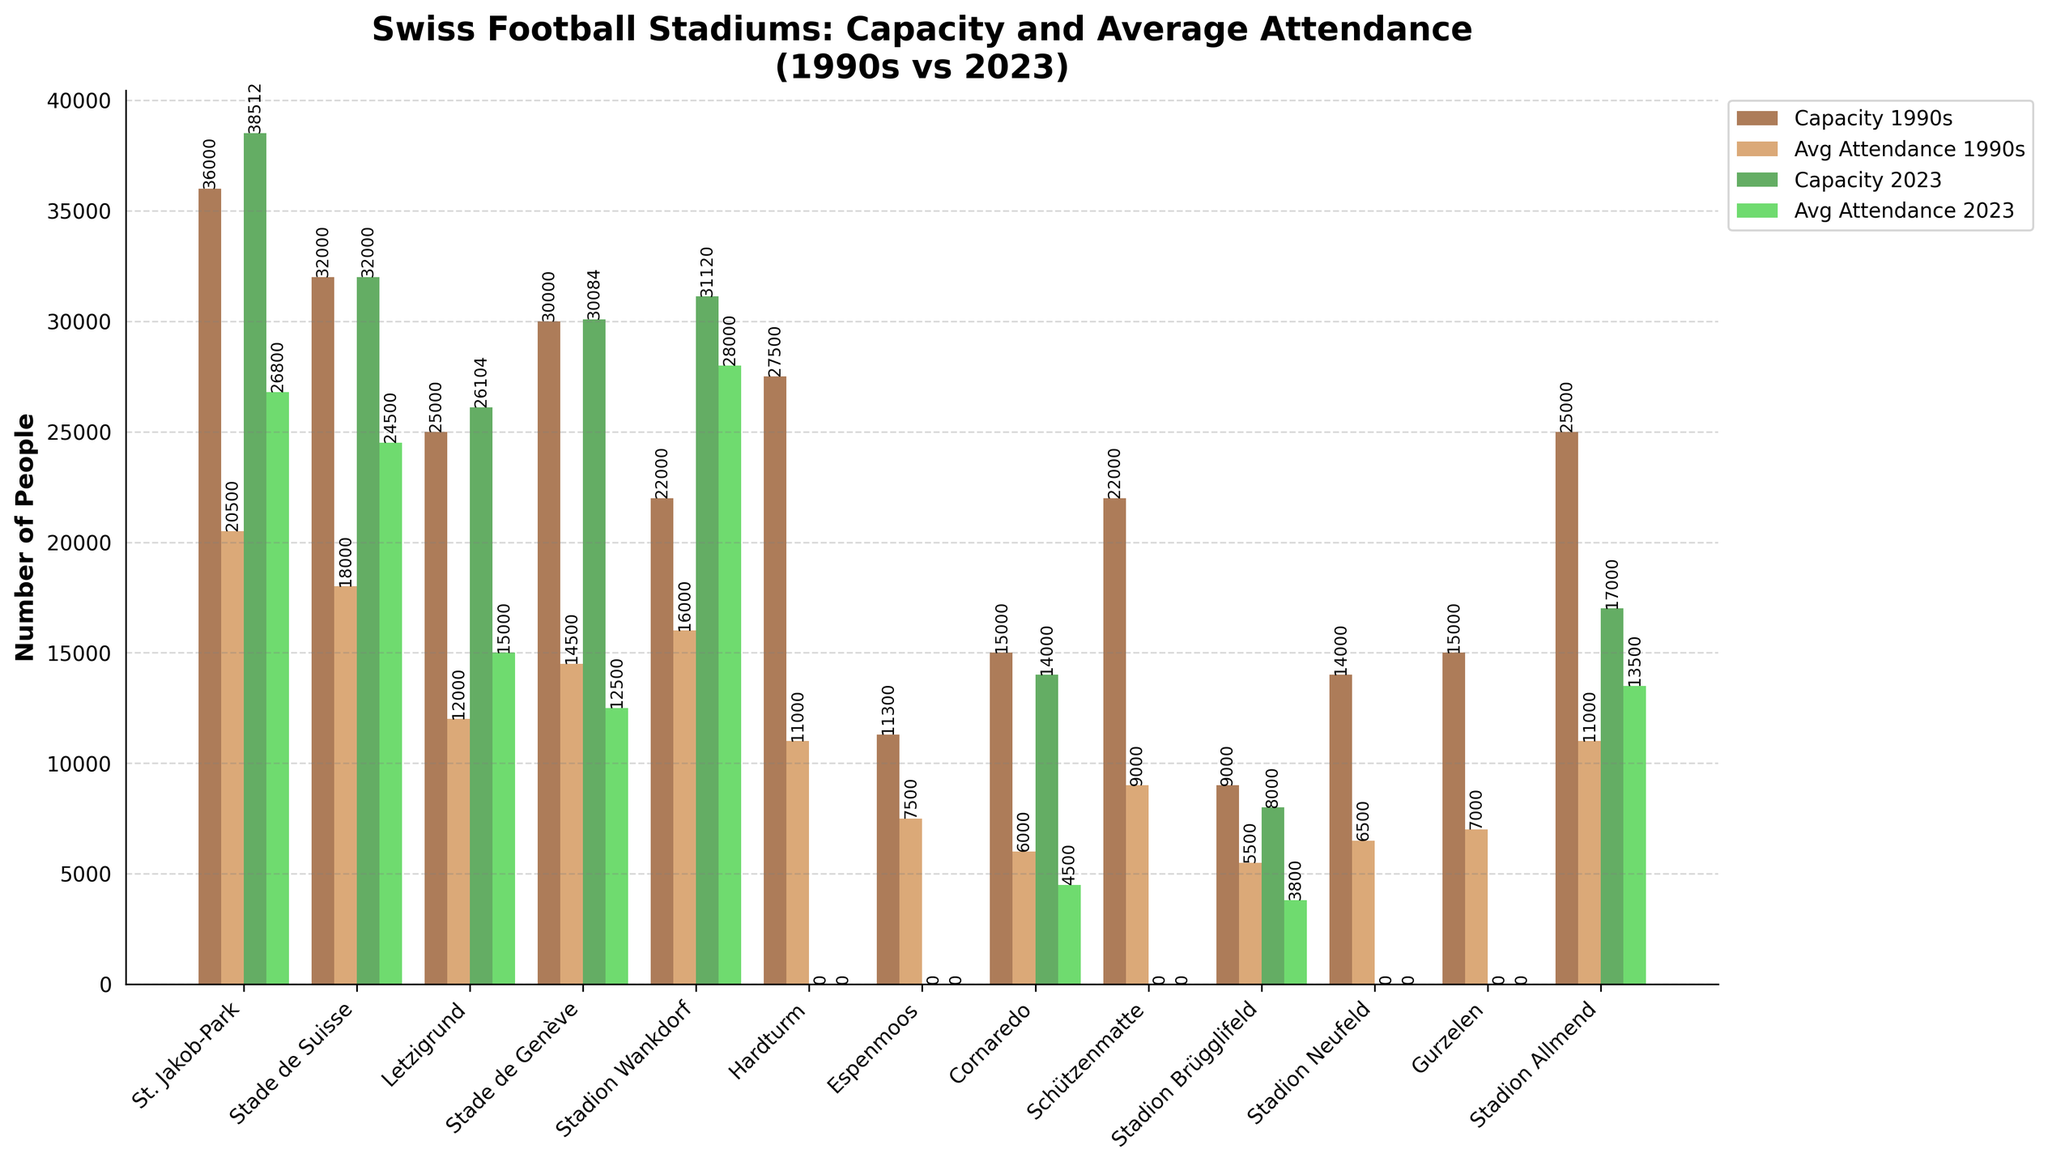How did the capacity of Stadion Wankdorf change from the 1990s to 2023? Comparing the bars for Stadion Wankdorf in the 1990s and 2023, we can see that the capacity increased from 22,000 to 31,120.
Answer: Increased by 9,120 Which stadium had the highest average attendance in the 1990s? By identifying the tallest bar in the 'Avg Attendance 1990s' group, we can see that Stadion Wankdorf had the highest average attendance of 16,000.
Answer: Stadion Wankdorf Comparing Cornaredo in the 1990s and 2023, what is the difference in average attendance? The average attendance at Cornaredo decreased from 6,000 in the 1990s to 4,500 in 2023. The difference is 6,000 - 4,500.
Answer: 1,500 Which stadium experienced the largest increase in average attendance from the 1990s to 2023? To determine this, we subtract the 1990s average attendance from the 2023 average attendance for each stadium. The largest increase is seen in Stadion Wankdorf, where attendance increased from 16,000 to 28,000.
Answer: Stadion Wankdorf For Letzigrund, what was the change in capacity and average attendance from the 1990s to 2023? By comparing the values, we find that the capacity changed from 25,000 to 26,104 (an increase of 1,104), and the average attendance changed from 12,000 to 15,000 (an increase of 3,000).
Answer: Capacity +1,104, Attendance +3,000 What is the total capacity of all stadiums in 2023? Adding the capacities of all stadiums in 2023: 38,512 + 32,000 + 26,104 + 30,084 + 31,120 + 14,000 + 8,000 + 17,000 = 196,820.
Answer: 196,820 Which stadium had no change in capacity from the 1990s to 2023? By inspecting the bars for capacity, Stade de Suisse has a consistent capacity of 32,000 in both periods.
Answer: Stade de Suisse What is the average capacity of stadiums in the 1990s? To find the average, sum all capacities in the 1990s and divide by the number of stadiums: (36,000 + 32,000 + 25,000 + 30,000 + 22,000 + 27,500 + 11,300 + 15,000 + 22,000 + 9,000 + 14,000 + 15,000 + 25,000) / 13. The sum is 273,800, thus average = 273,800 / 13 = 21,061.5.
Answer: 21,061.5 